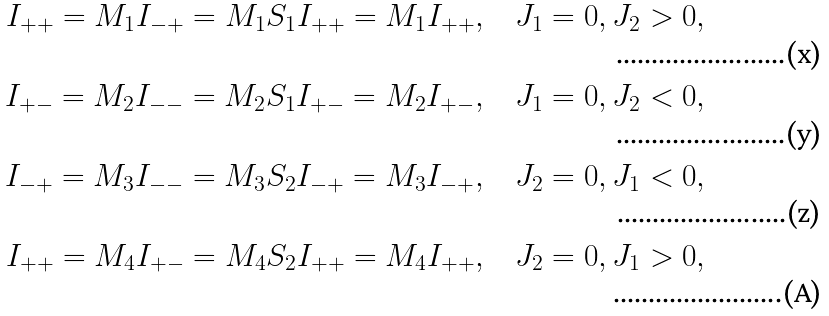Convert formula to latex. <formula><loc_0><loc_0><loc_500><loc_500>I _ { + + } = M _ { 1 } I _ { - + } = M _ { 1 } S _ { 1 } I _ { + + } = M _ { 1 } I _ { + + } , & \quad J _ { 1 } = 0 , J _ { 2 } > 0 , \\ I _ { + - } = M _ { 2 } I _ { - - } = M _ { 2 } S _ { 1 } I _ { + - } = M _ { 2 } I _ { + - } , & \quad J _ { 1 } = 0 , J _ { 2 } < 0 , \\ I _ { - + } = M _ { 3 } I _ { - - } = M _ { 3 } S _ { 2 } I _ { - + } = M _ { 3 } I _ { - + } , & \quad J _ { 2 } = 0 , J _ { 1 } < 0 , \\ I _ { + + } = M _ { 4 } I _ { + - } = M _ { 4 } S _ { 2 } I _ { + + } = M _ { 4 } I _ { + + } , & \quad J _ { 2 } = 0 , J _ { 1 } > 0 ,</formula> 